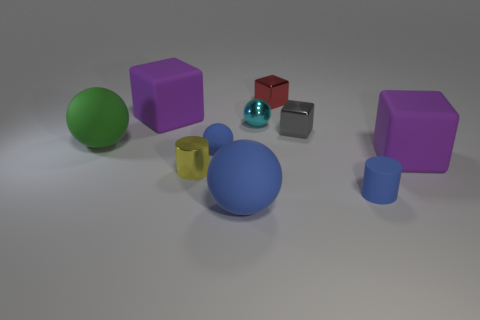There is a green thing that is the same material as the big blue ball; what size is it?
Ensure brevity in your answer.  Large. There is a small red shiny block; are there any big purple rubber objects right of it?
Your answer should be compact. Yes. There is a cyan shiny object that is the same shape as the green rubber thing; what is its size?
Ensure brevity in your answer.  Small. There is a shiny ball; does it have the same color as the large sphere that is on the right side of the big green thing?
Your answer should be compact. No. Does the tiny rubber ball have the same color as the rubber cylinder?
Your answer should be very brief. Yes. Are there fewer large green objects than purple cylinders?
Give a very brief answer. No. What number of other objects are there of the same color as the shiny sphere?
Provide a succinct answer. 0. How many small green shiny things are there?
Provide a short and direct response. 0. Is the number of tiny matte cylinders that are in front of the tiny matte cylinder less than the number of big purple rubber cubes?
Keep it short and to the point. Yes. Do the blue thing to the left of the big blue ball and the red object have the same material?
Your response must be concise. No. 